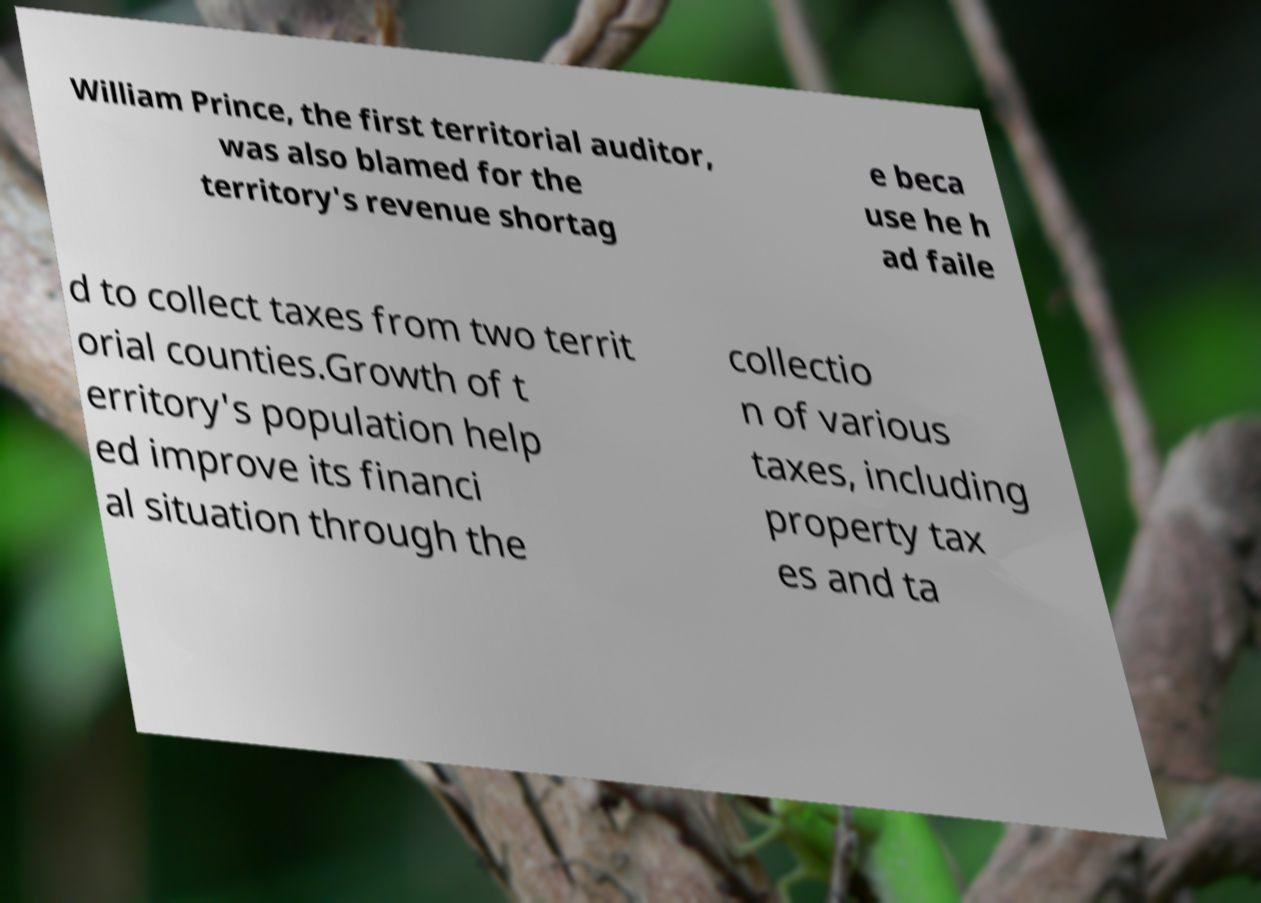There's text embedded in this image that I need extracted. Can you transcribe it verbatim? William Prince, the first territorial auditor, was also blamed for the territory's revenue shortag e beca use he h ad faile d to collect taxes from two territ orial counties.Growth of t erritory's population help ed improve its financi al situation through the collectio n of various taxes, including property tax es and ta 